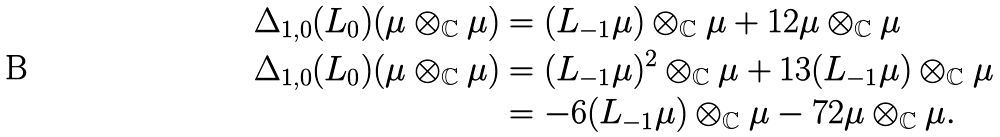Convert formula to latex. <formula><loc_0><loc_0><loc_500><loc_500>\Delta _ { 1 , 0 } ( L _ { 0 } ) ( \mu \otimes _ { \mathbb { C } } \mu ) & = ( L _ { - 1 } \mu ) \otimes _ { \mathbb { C } } \mu + 1 2 \mu \otimes _ { \mathbb { C } } \mu \\ \Delta _ { 1 , 0 } ( L _ { 0 } ) ( \mu \otimes _ { \mathbb { C } } \mu ) & = ( L _ { - 1 } \mu ) ^ { 2 } \otimes _ { \mathbb { C } } \mu + 1 3 ( L _ { - 1 } \mu ) \otimes _ { \mathbb { C } } \mu \\ & = - 6 ( L _ { - 1 } \mu ) \otimes _ { \mathbb { C } } \mu - 7 2 \mu \otimes _ { \mathbb { C } } \mu .</formula> 